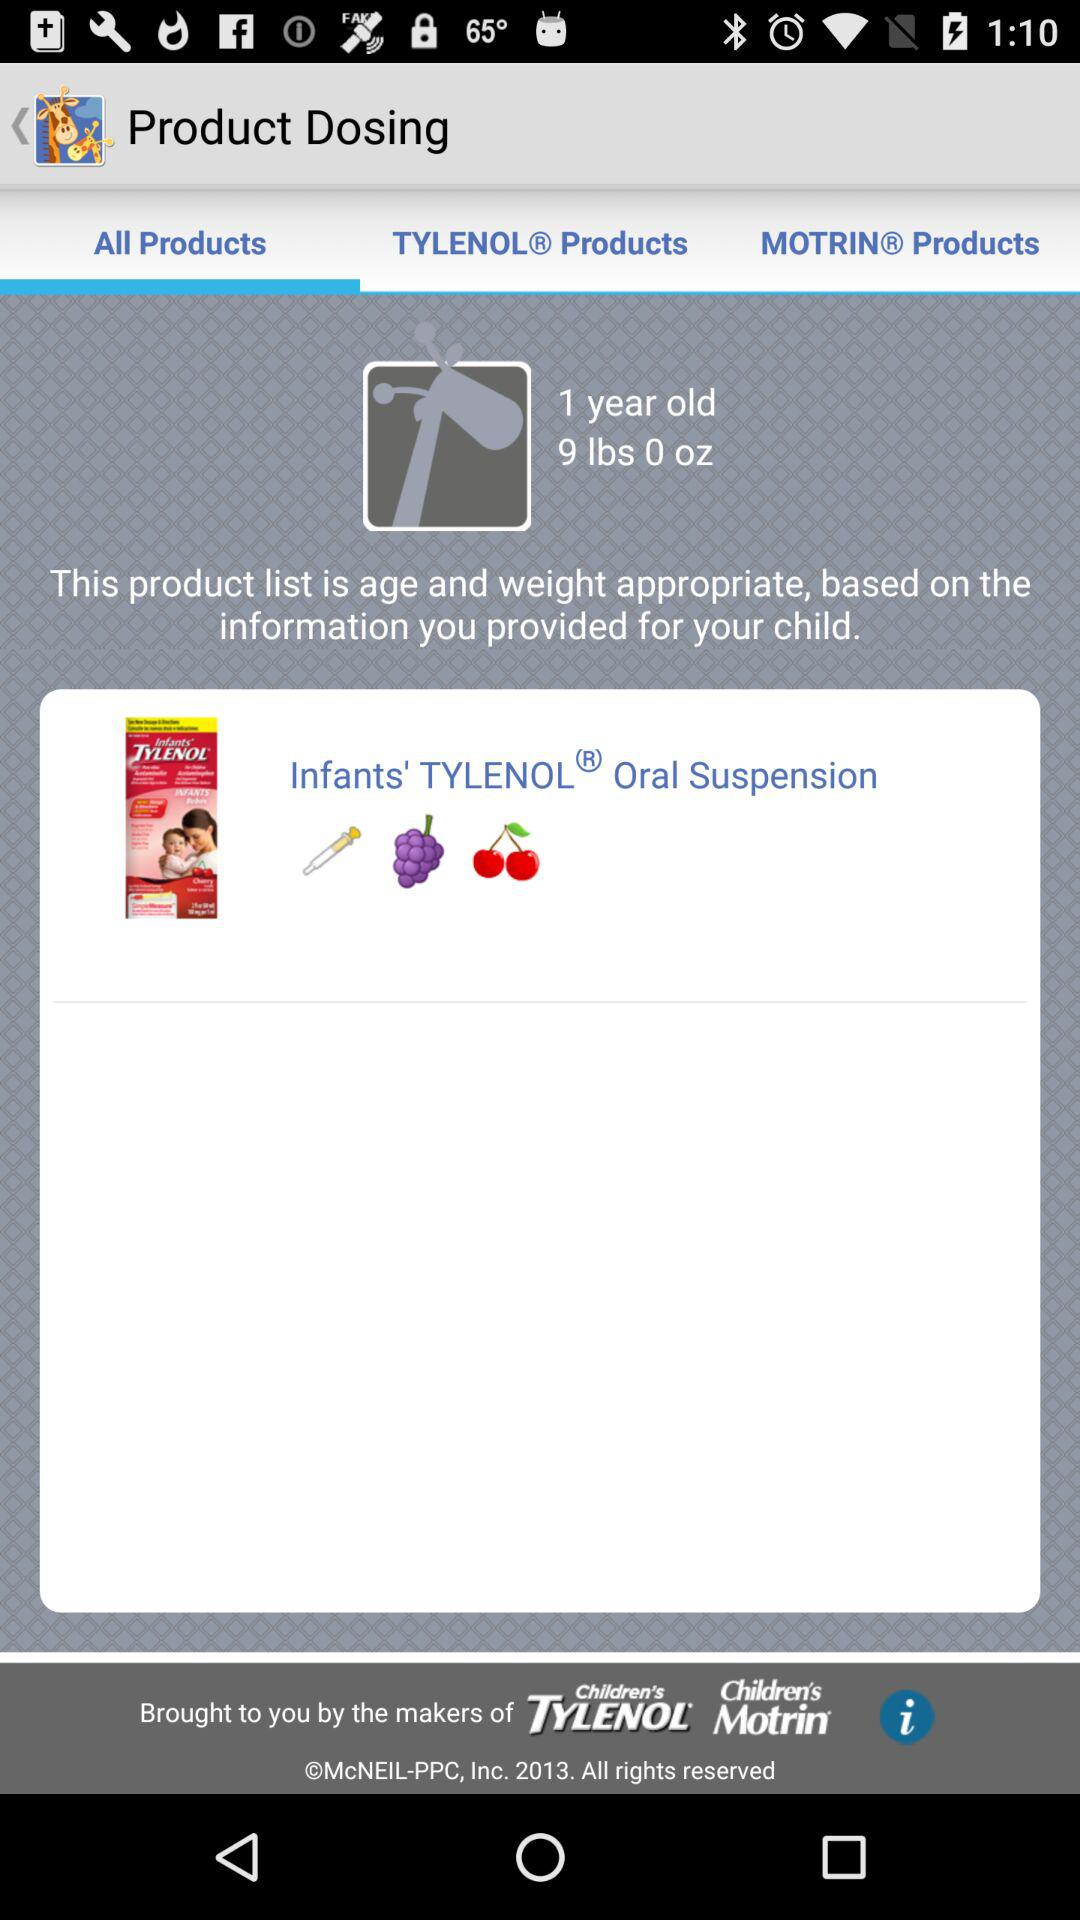What is the dosage for 1 year old child?
When the provided information is insufficient, respond with <no answer>. <no answer> 